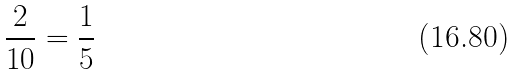Convert formula to latex. <formula><loc_0><loc_0><loc_500><loc_500>\frac { 2 } { 1 0 } = \frac { 1 } { 5 }</formula> 